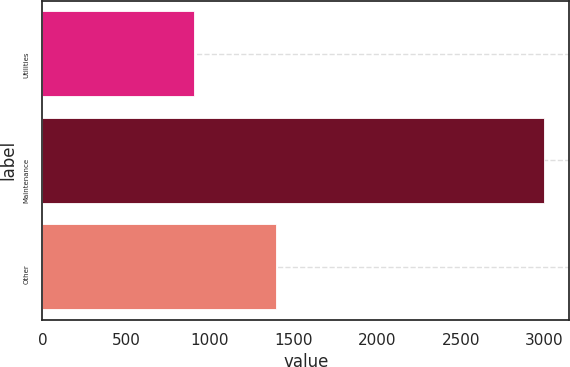<chart> <loc_0><loc_0><loc_500><loc_500><bar_chart><fcel>Utilities<fcel>Maintenance<fcel>Other<nl><fcel>906<fcel>2997<fcel>1394<nl></chart> 